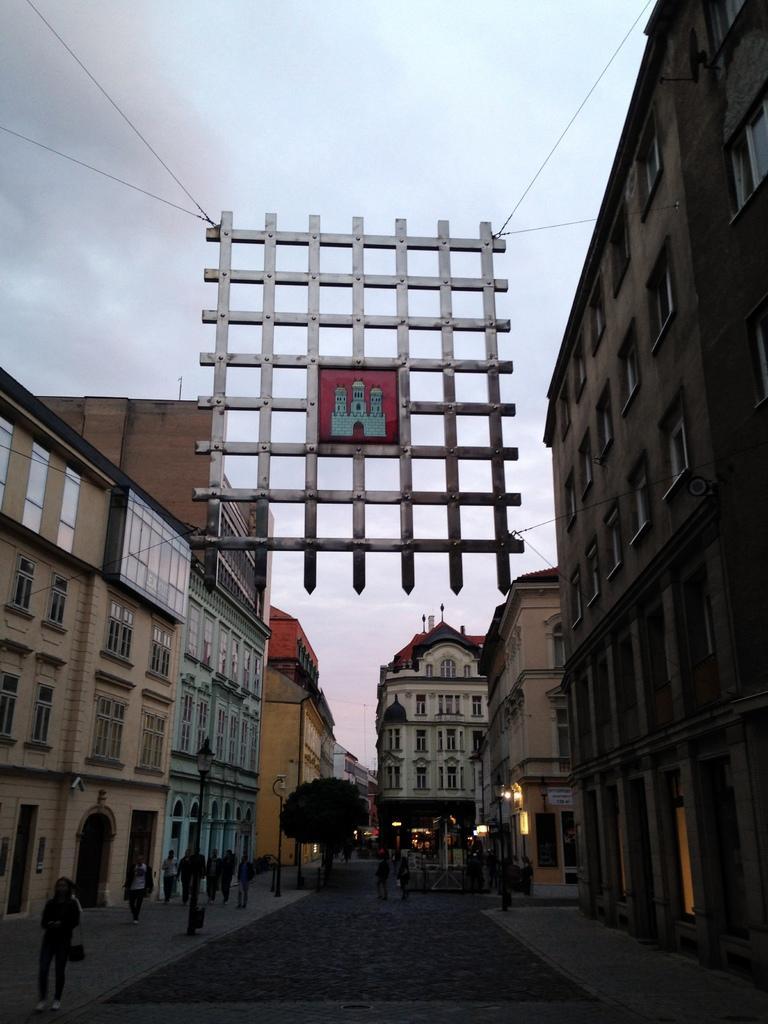In one or two sentences, can you explain what this image depicts? In this picture there are people and a trees at the bottom side of the image and there are buildings on the right and left side of the image, there are lamps in the image, there is a square shape net in the center of the image. 